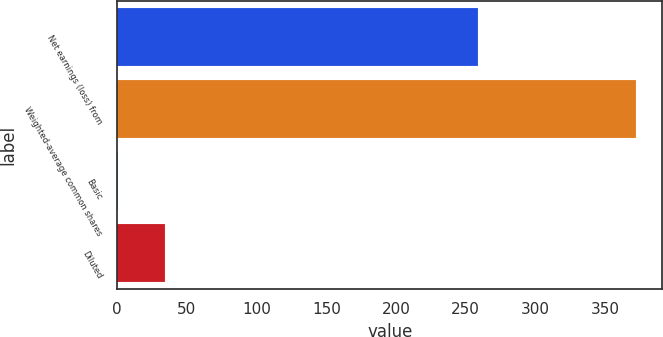<chart> <loc_0><loc_0><loc_500><loc_500><bar_chart><fcel>Net earnings (loss) from<fcel>Weighted-average common shares<fcel>Basic<fcel>Diluted<nl><fcel>259<fcel>372.38<fcel>0.76<fcel>34.54<nl></chart> 